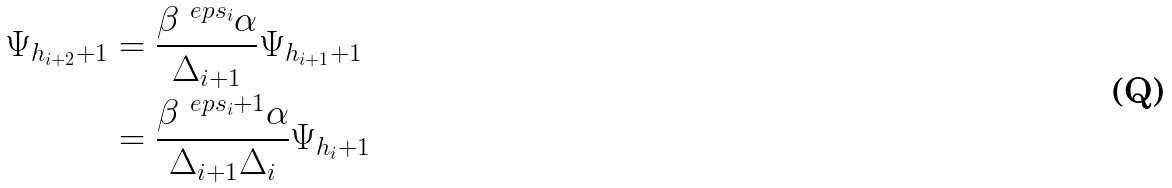<formula> <loc_0><loc_0><loc_500><loc_500>\Psi _ { h _ { i + 2 } + 1 } & = \frac { \beta ^ { \ e p s _ { i } } \alpha } { \Delta _ { i + 1 } } \Psi _ { h _ { i + 1 } + 1 } \\ & = \frac { \beta ^ { \ e p s _ { i } + 1 } \alpha } { \Delta _ { i + 1 } \Delta _ { i } } \Psi _ { h _ { i } + 1 }</formula> 